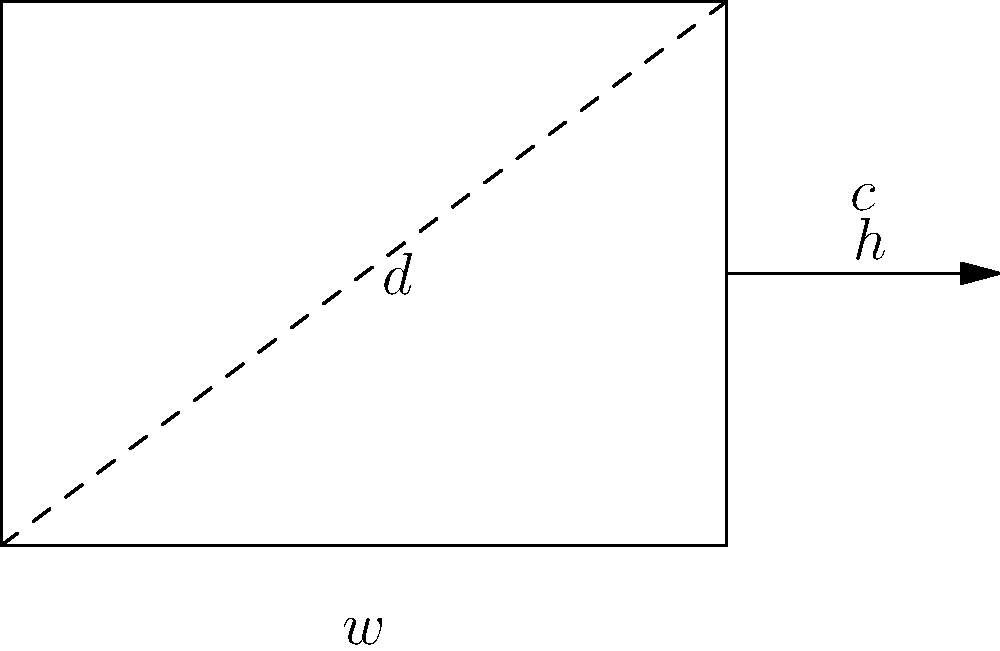Dr. Amira needs to measure the circumference of your bandaged arm. She explains that the arm's cross-section can be approximated as a rectangle. If the width of your arm is 4 inches and the height is 3 inches, what is the circumference of the bandage needed? Round your answer to the nearest inch. Let's approach this step-by-step:

1) The cross-section of the arm is approximated as a rectangle.

2) For a rectangle:
   - Width ($w$) = 4 inches
   - Height ($h$) = 3 inches

3) The circumference of a rectangle is given by the formula:
   $c = 2w + 2h$

4) Let's substitute the values:
   $c = 2(4) + 2(3)$

5) Simplify:
   $c = 8 + 6 = 14$ inches

6) The question asks to round to the nearest inch, but 14 is already a whole number, so no rounding is necessary.

Therefore, the circumference of the bandage needed is 14 inches.
Answer: 14 inches 